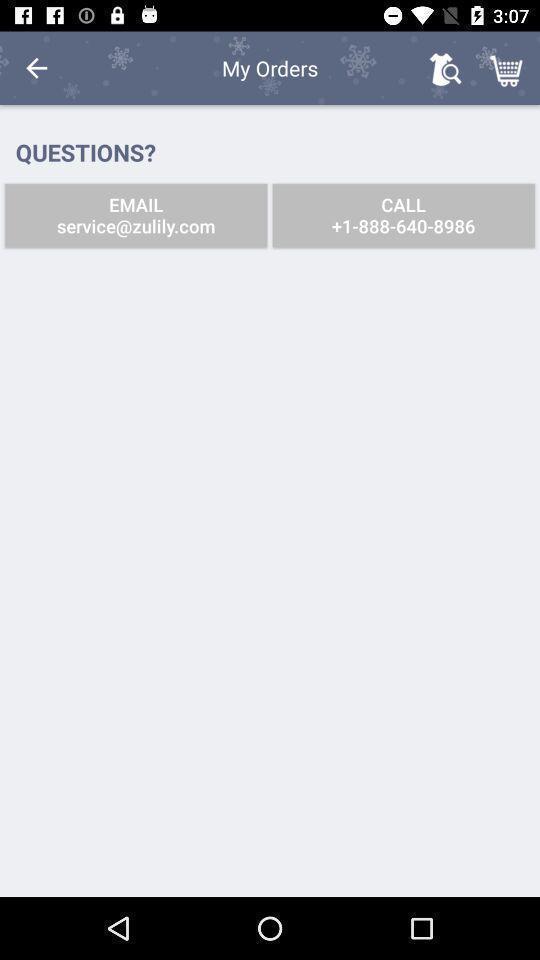Please provide a description for this image. Screen shows orders details in a shopping app. 